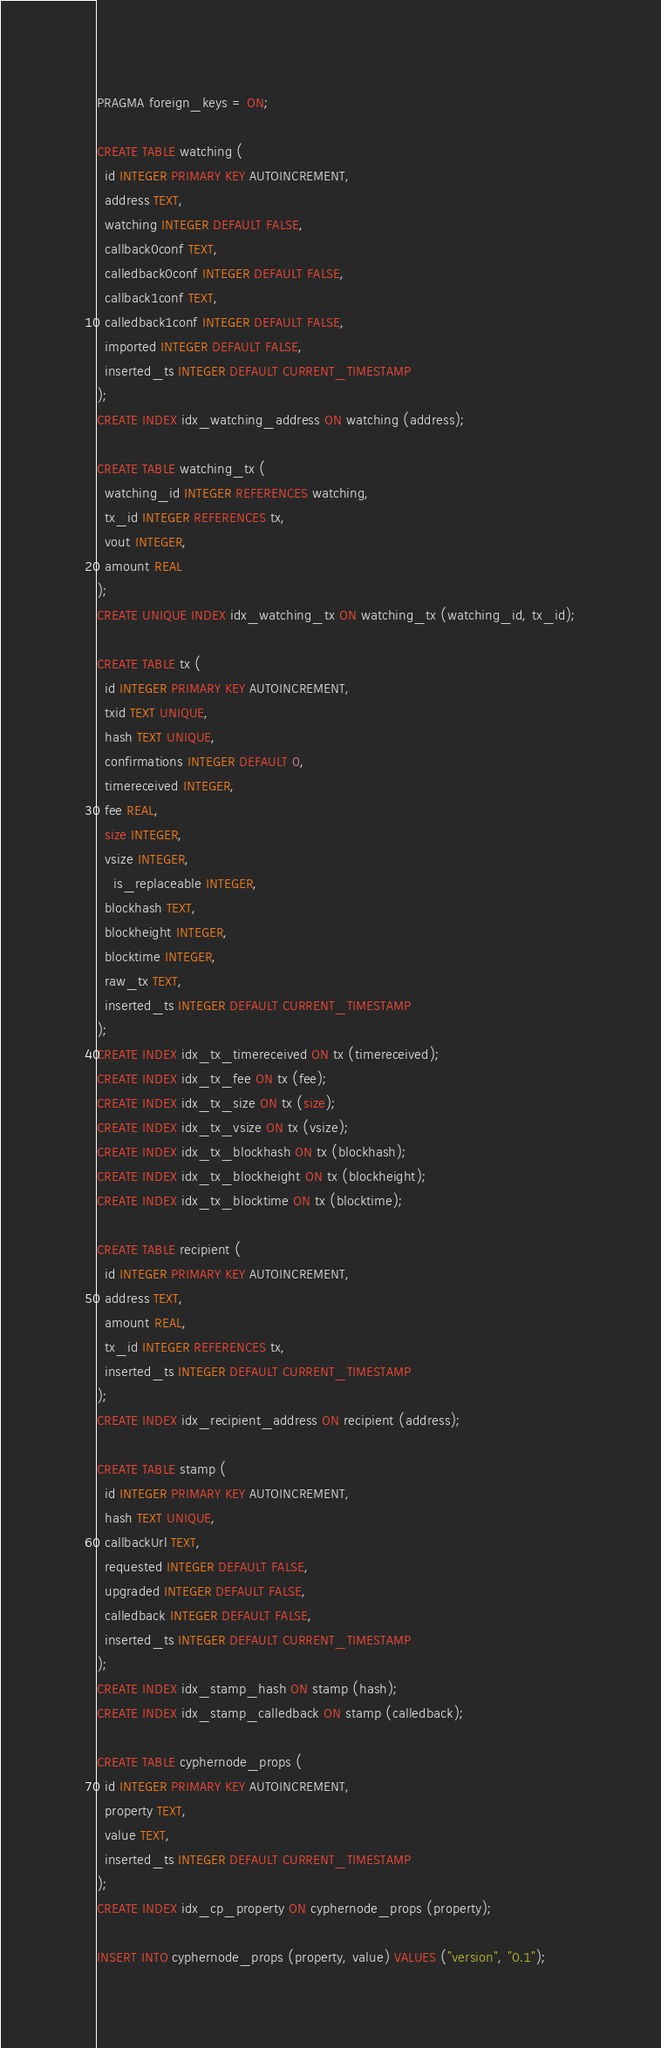<code> <loc_0><loc_0><loc_500><loc_500><_SQL_>PRAGMA foreign_keys = ON;

CREATE TABLE watching (
  id INTEGER PRIMARY KEY AUTOINCREMENT,
  address TEXT,
  watching INTEGER DEFAULT FALSE,
  callback0conf TEXT,
  calledback0conf INTEGER DEFAULT FALSE,
  callback1conf TEXT,
  calledback1conf INTEGER DEFAULT FALSE,
  imported INTEGER DEFAULT FALSE,
  inserted_ts INTEGER DEFAULT CURRENT_TIMESTAMP
);
CREATE INDEX idx_watching_address ON watching (address);

CREATE TABLE watching_tx (
  watching_id INTEGER REFERENCES watching,
  tx_id INTEGER REFERENCES tx,
  vout INTEGER,
  amount REAL
);
CREATE UNIQUE INDEX idx_watching_tx ON watching_tx (watching_id, tx_id);

CREATE TABLE tx (
  id INTEGER PRIMARY KEY AUTOINCREMENT,
  txid TEXT UNIQUE,
  hash TEXT UNIQUE,
  confirmations INTEGER DEFAULT 0,
  timereceived INTEGER,
  fee REAL,
  size INTEGER,
  vsize INTEGER,
	is_replaceable INTEGER,
  blockhash TEXT,
  blockheight INTEGER,
  blocktime INTEGER,
  raw_tx TEXT,
  inserted_ts INTEGER DEFAULT CURRENT_TIMESTAMP
);
CREATE INDEX idx_tx_timereceived ON tx (timereceived);
CREATE INDEX idx_tx_fee ON tx (fee);
CREATE INDEX idx_tx_size ON tx (size);
CREATE INDEX idx_tx_vsize ON tx (vsize);
CREATE INDEX idx_tx_blockhash ON tx (blockhash);
CREATE INDEX idx_tx_blockheight ON tx (blockheight);
CREATE INDEX idx_tx_blocktime ON tx (blocktime);

CREATE TABLE recipient (
  id INTEGER PRIMARY KEY AUTOINCREMENT,
  address TEXT,
  amount REAL,
  tx_id INTEGER REFERENCES tx,
  inserted_ts INTEGER DEFAULT CURRENT_TIMESTAMP
);
CREATE INDEX idx_recipient_address ON recipient (address);

CREATE TABLE stamp (
  id INTEGER PRIMARY KEY AUTOINCREMENT,
  hash TEXT UNIQUE,
  callbackUrl TEXT,
  requested INTEGER DEFAULT FALSE,
  upgraded INTEGER DEFAULT FALSE,
  calledback INTEGER DEFAULT FALSE,
  inserted_ts INTEGER DEFAULT CURRENT_TIMESTAMP
);
CREATE INDEX idx_stamp_hash ON stamp (hash);
CREATE INDEX idx_stamp_calledback ON stamp (calledback);

CREATE TABLE cyphernode_props (
  id INTEGER PRIMARY KEY AUTOINCREMENT,
  property TEXT,
  value TEXT,
  inserted_ts INTEGER DEFAULT CURRENT_TIMESTAMP
);
CREATE INDEX idx_cp_property ON cyphernode_props (property);

INSERT INTO cyphernode_props (property, value) VALUES ("version", "0.1");
</code> 